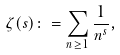Convert formula to latex. <formula><loc_0><loc_0><loc_500><loc_500>\zeta ( s ) \colon = \sum _ { n \geq 1 } \frac { 1 } { n ^ { s } } ,</formula> 